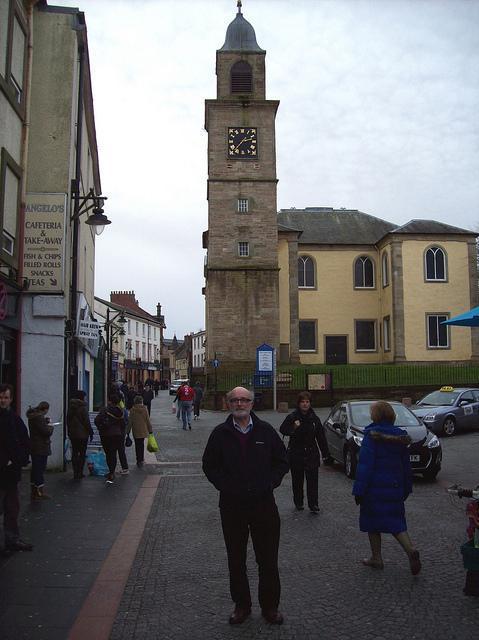How many arched windows are on the church?
Give a very brief answer. 3. How many clocks are on the tower?
Give a very brief answer. 1. How many red shirts are there?
Give a very brief answer. 1. How many floors the right building has?
Give a very brief answer. 2. How many of these people are riding skateboards?
Give a very brief answer. 0. How many cabs are there?
Give a very brief answer. 1. How many people are there?
Give a very brief answer. 6. How many cars are in the photo?
Give a very brief answer. 2. 